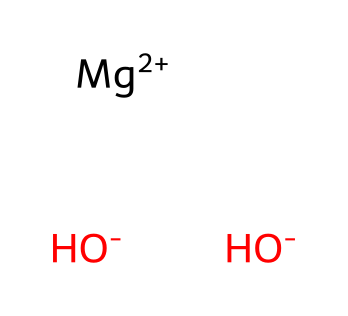What is the name of this compound? The chemical structure indicates the presence of magnesium and hydroxide ions. The combination of these elements forms magnesium hydroxide.
Answer: magnesium hydroxide How many hydroxide ions are present in this chemical? The SMILES representation shows two hydroxide ions denoted by [OH-]. Therefore, there are two hydroxide ions in this compound.
Answer: two What is the charge of the magnesium ion in this compound? The SMILES notation shows [Mg+2], which indicates that the magnesium ion has a +2 charge.
Answer: +2 What type of chemical is magnesium hydroxide classified as? Magnesium hydroxide is classified as a base because it contains hydroxide ions, which increase the pH and can neutralize acids.
Answer: base How many total atoms are present in magnesium hydroxide? Analyzing the structure: 1 magnesium atom and 2 oxygen atoms in the hydroxide plus 2 hydrogen atoms gives a total of 5 atoms (1+2+2).
Answer: five Is magnesium hydroxide likely to change the acidity of a solution? Yes, as a base, magnesium hydroxide will react with acids to neutralize them, thus changing the acidity of the solution.
Answer: yes What common usage does magnesium hydroxide have related to sports? Magnesium hydroxide is commonly used in antacids to relieve indigestion, which can be relevant for athletes experiencing digestive issues.
Answer: antacid 